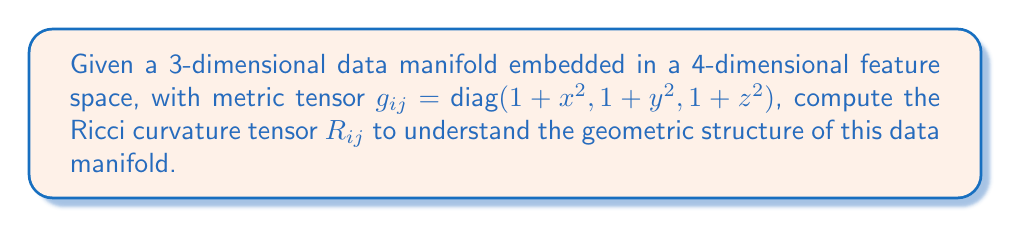Give your solution to this math problem. To compute the Ricci curvature tensor, we'll follow these steps:

1) First, we need to calculate the Christoffel symbols $\Gamma^k_{ij}$:
   $$\Gamma^k_{ij} = \frac{1}{2}g^{kl}(\partial_i g_{jl} + \partial_j g_{il} - \partial_l g_{ij})$$

   Given the metric, we can see that:
   $$g^{ij} = \text{diag}(\frac{1}{1+x^2}, \frac{1}{1+y^2}, \frac{1}{1+z^2})$$

2) Calculating the non-zero Christoffel symbols:
   $$\Gamma^1_{11} = \frac{x}{1+x^2}, \Gamma^2_{22} = \frac{y}{1+y^2}, \Gamma^3_{33} = \frac{z}{1+z^2}$$

3) Next, we calculate the Riemann curvature tensor:
   $$R^i_{jkl} = \partial_k \Gamma^i_{jl} - \partial_l \Gamma^i_{jk} + \Gamma^i_{km}\Gamma^m_{jl} - \Gamma^i_{lm}\Gamma^m_{jk}$$

4) The non-zero components of the Riemann tensor are:
   $$R^1_{212} = -\frac{x^2}{(1+x^2)^2}, R^2_{121} = \frac{y^2}{(1+y^2)^2}, R^3_{131} = \frac{z^2}{(1+z^2)^2}$$
   $$R^1_{313} = -\frac{x^2}{(1+x^2)^2}, R^2_{323} = -\frac{y^2}{(1+y^2)^2}, R^3_{232} = \frac{z^2}{(1+z^2)^2}$$

5) The Ricci tensor is the contraction of the Riemann tensor:
   $$R_{ij} = R^k_{ikj}$$

6) Computing the components of the Ricci tensor:
   $$R_{11} = R^2_{121} + R^3_{131} = \frac{y^2}{(1+y^2)^2} + \frac{z^2}{(1+z^2)^2}$$
   $$R_{22} = R^1_{212} + R^3_{232} = -\frac{x^2}{(1+x^2)^2} + \frac{z^2}{(1+z^2)^2}$$
   $$R_{33} = R^1_{313} + R^2_{323} = -\frac{x^2}{(1+x^2)^2} - \frac{y^2}{(1+y^2)^2}$$

Therefore, the Ricci curvature tensor for this data manifold is:
$$R_{ij} = \begin{pmatrix}
\frac{y^2}{(1+y^2)^2} + \frac{z^2}{(1+z^2)^2} & 0 & 0 \\
0 & -\frac{x^2}{(1+x^2)^2} + \frac{z^2}{(1+z^2)^2} & 0 \\
0 & 0 & -\frac{x^2}{(1+x^2)^2} - \frac{y^2}{(1+y^2)^2}
\end{pmatrix}$$
Answer: $$R_{ij} = \text{diag}\left(\frac{y^2}{(1+y^2)^2} + \frac{z^2}{(1+z^2)^2}, -\frac{x^2}{(1+x^2)^2} + \frac{z^2}{(1+z^2)^2}, -\frac{x^2}{(1+x^2)^2} - \frac{y^2}{(1+y^2)^2}\right)$$ 